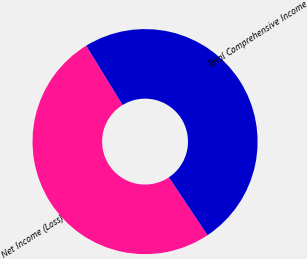Convert chart. <chart><loc_0><loc_0><loc_500><loc_500><pie_chart><fcel>Net Income (Loss)<fcel>Total Comprehensive Income<nl><fcel>50.61%<fcel>49.39%<nl></chart> 